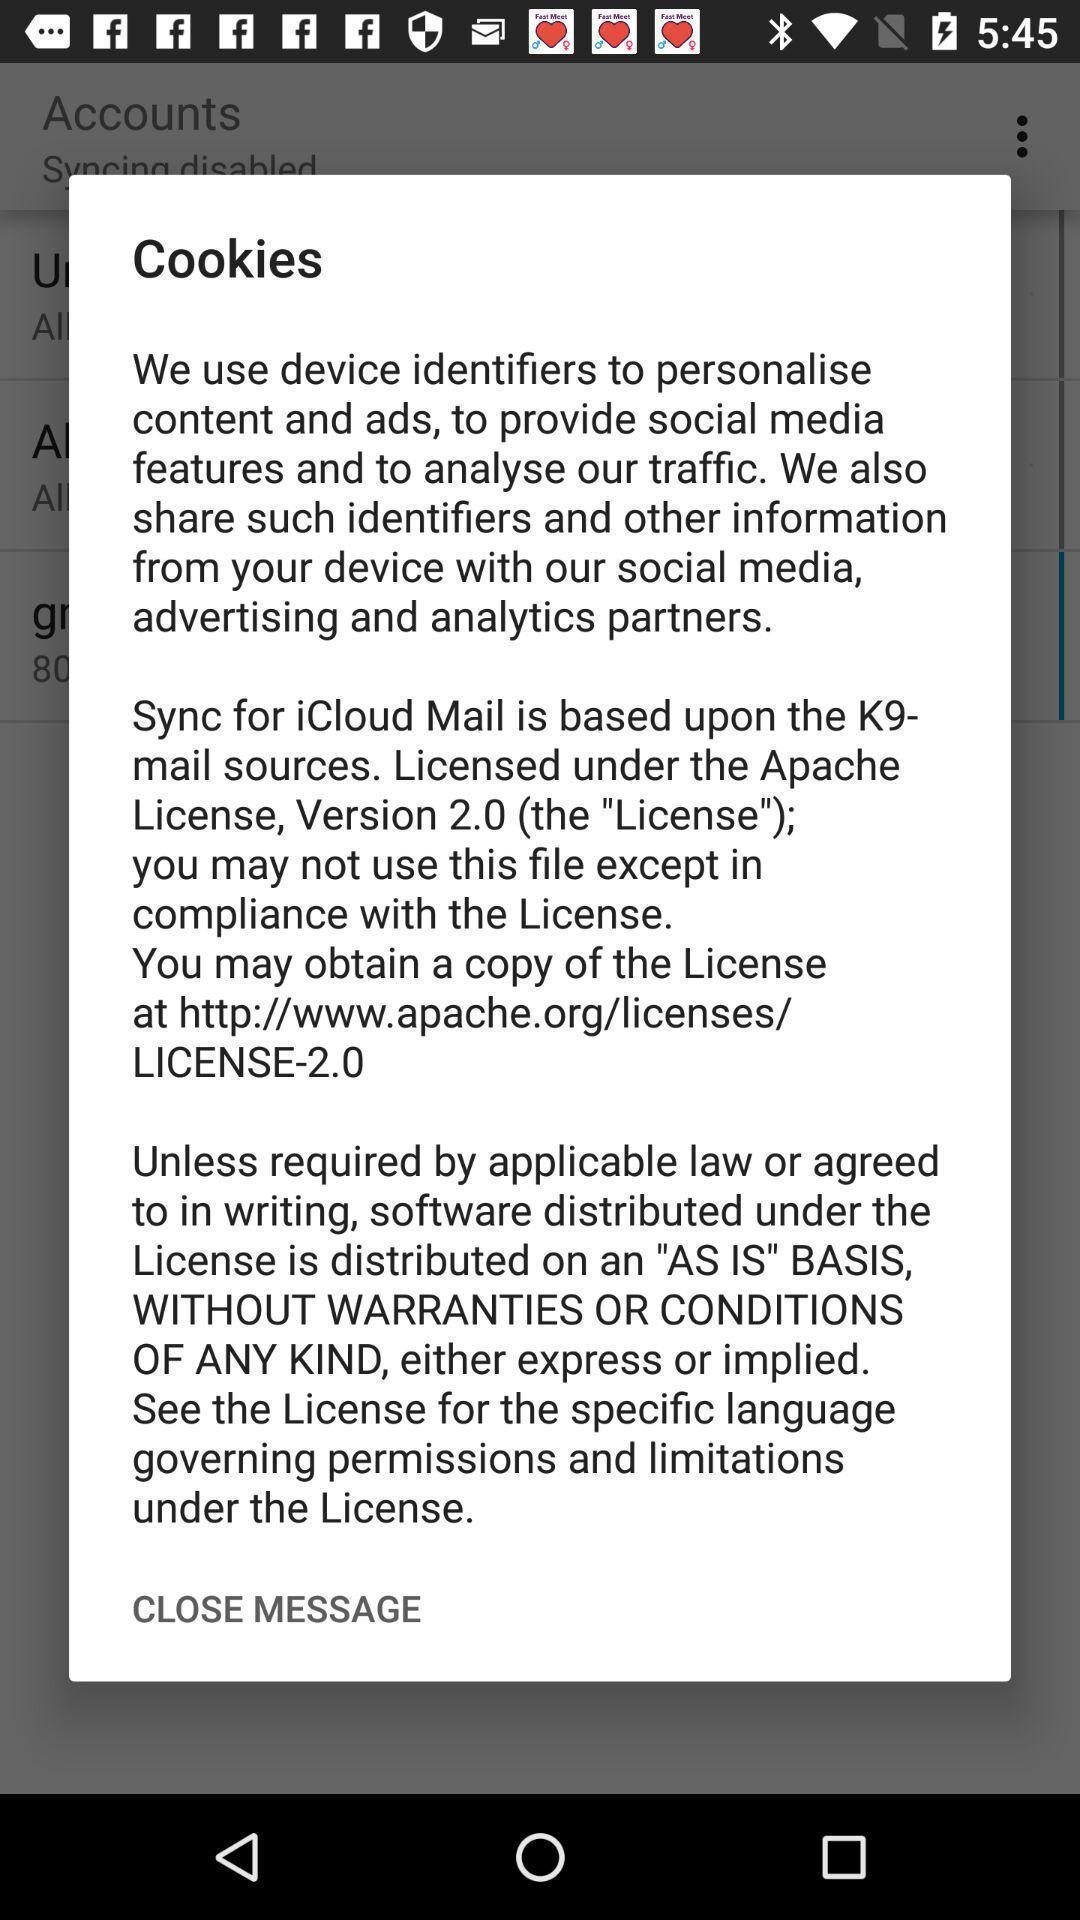Provide a description of this screenshot. Popup showing information about cookies. 